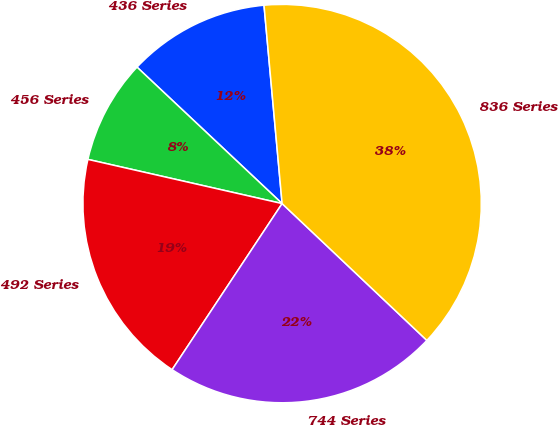Convert chart. <chart><loc_0><loc_0><loc_500><loc_500><pie_chart><fcel>436 Series<fcel>456 Series<fcel>492 Series<fcel>744 Series<fcel>836 Series<nl><fcel>11.54%<fcel>8.45%<fcel>19.25%<fcel>22.26%<fcel>38.5%<nl></chart> 